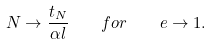Convert formula to latex. <formula><loc_0><loc_0><loc_500><loc_500>N \to \frac { t _ { N } } { \alpha l } \quad f o r \quad e \to 1 .</formula> 